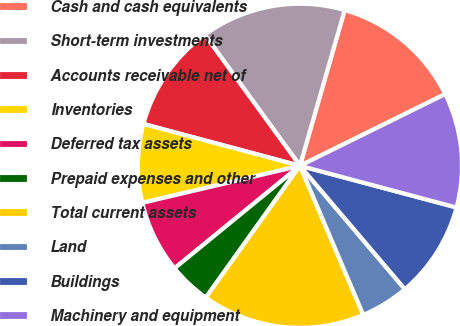<chart> <loc_0><loc_0><loc_500><loc_500><pie_chart><fcel>Cash and cash equivalents<fcel>Short-term investments<fcel>Accounts receivable net of<fcel>Inventories<fcel>Deferred tax assets<fcel>Prepaid expenses and other<fcel>Total current assets<fcel>Land<fcel>Buildings<fcel>Machinery and equipment<nl><fcel>13.25%<fcel>14.45%<fcel>10.84%<fcel>7.83%<fcel>7.23%<fcel>4.22%<fcel>16.26%<fcel>4.82%<fcel>9.64%<fcel>11.44%<nl></chart> 